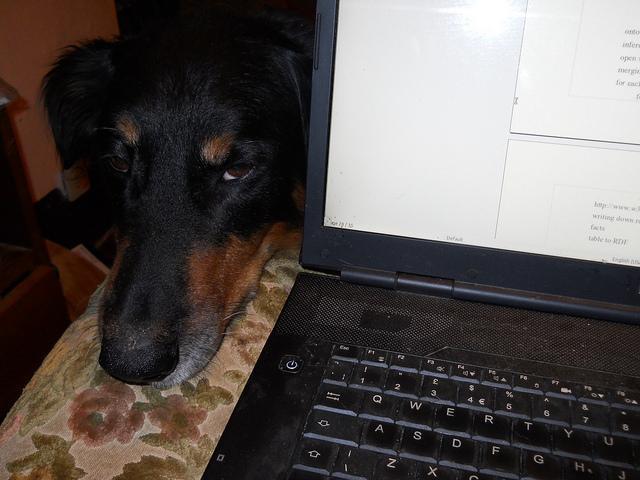How many laptops can be seen?
Give a very brief answer. 1. 